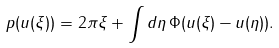Convert formula to latex. <formula><loc_0><loc_0><loc_500><loc_500>p ( u ( \xi ) ) = 2 \pi \xi + \int d \eta \, \Phi ( u ( \xi ) - u ( \eta ) ) .</formula> 